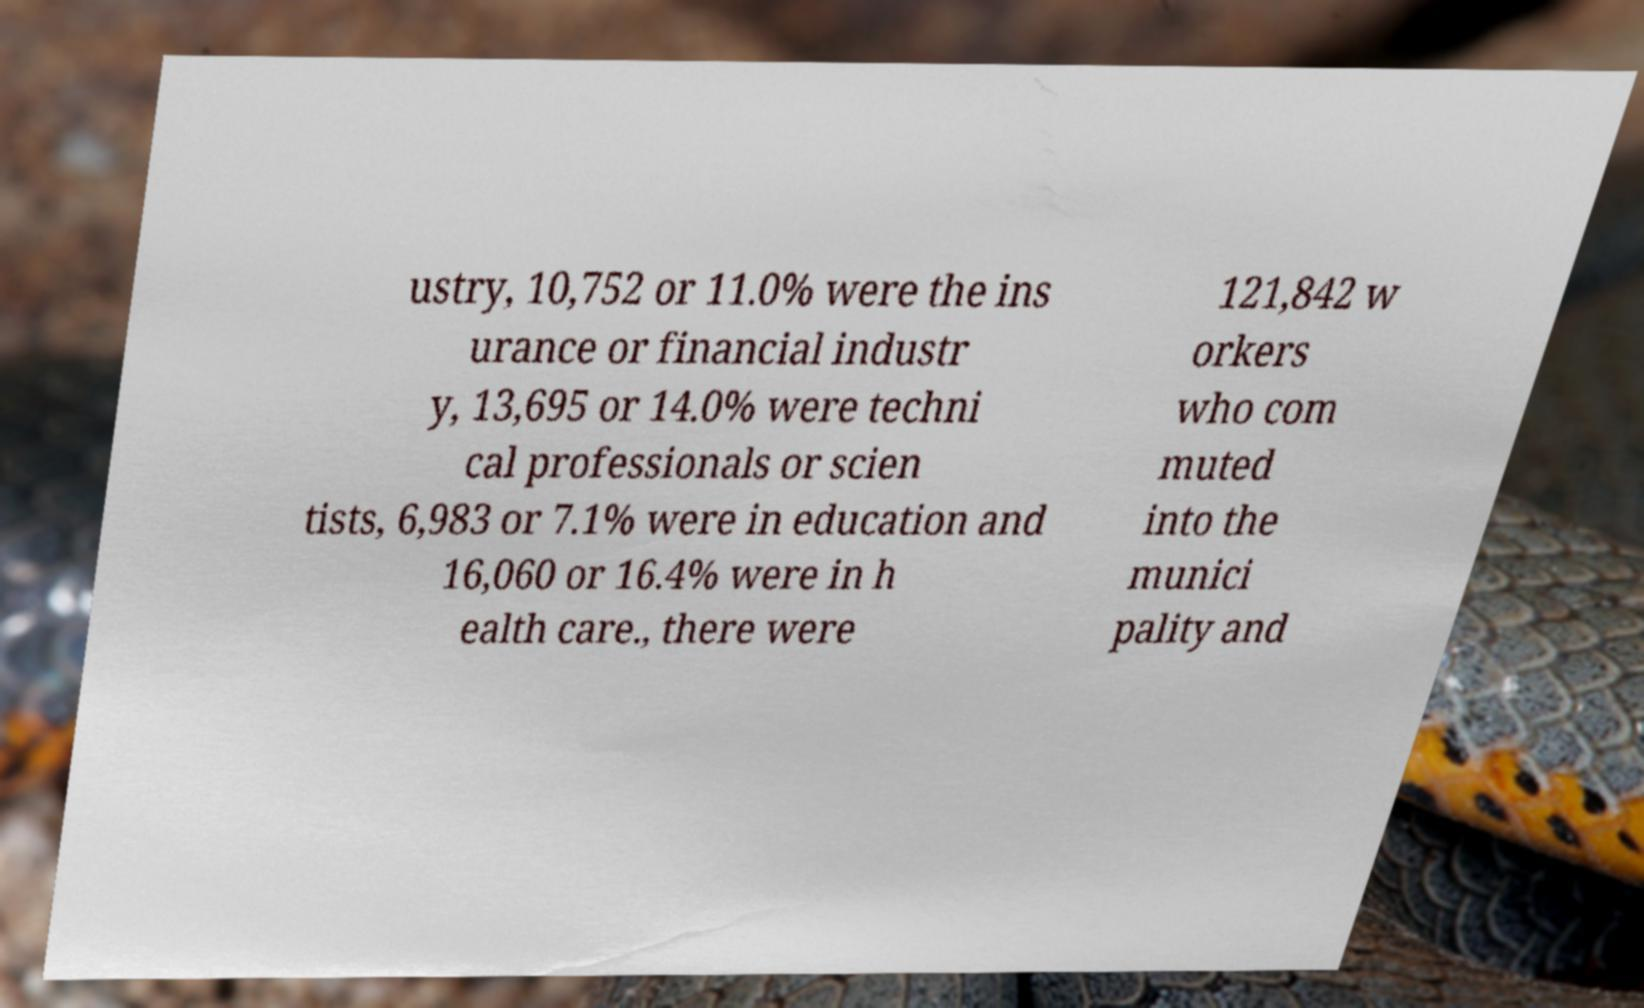There's text embedded in this image that I need extracted. Can you transcribe it verbatim? ustry, 10,752 or 11.0% were the ins urance or financial industr y, 13,695 or 14.0% were techni cal professionals or scien tists, 6,983 or 7.1% were in education and 16,060 or 16.4% were in h ealth care., there were 121,842 w orkers who com muted into the munici pality and 